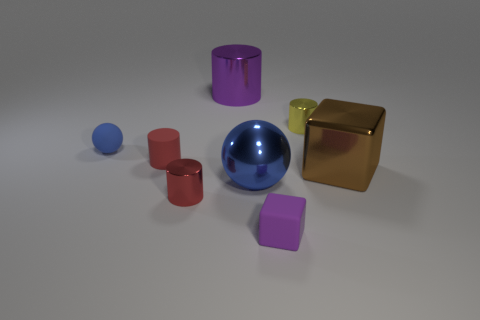What is the shape of the small metal object that is the same color as the tiny matte cylinder?
Your response must be concise. Cylinder. Are there any other things that are the same color as the tiny block?
Keep it short and to the point. Yes. Do the matte ball and the metallic ball have the same color?
Ensure brevity in your answer.  Yes. There is a tiny cube; does it have the same color as the large object that is behind the tiny yellow metal cylinder?
Your response must be concise. Yes. What color is the small cylinder right of the blue shiny thing?
Your response must be concise. Yellow. How many shiny objects are on the left side of the brown cube and behind the red metallic cylinder?
Offer a terse response. 3. What is the shape of the blue metallic object that is the same size as the brown metal object?
Make the answer very short. Sphere. The red rubber cylinder has what size?
Offer a very short reply. Small. The block that is in front of the blue object that is in front of the large brown object in front of the tiny red rubber thing is made of what material?
Offer a very short reply. Rubber. What color is the cylinder that is the same material as the tiny blue ball?
Keep it short and to the point. Red. 